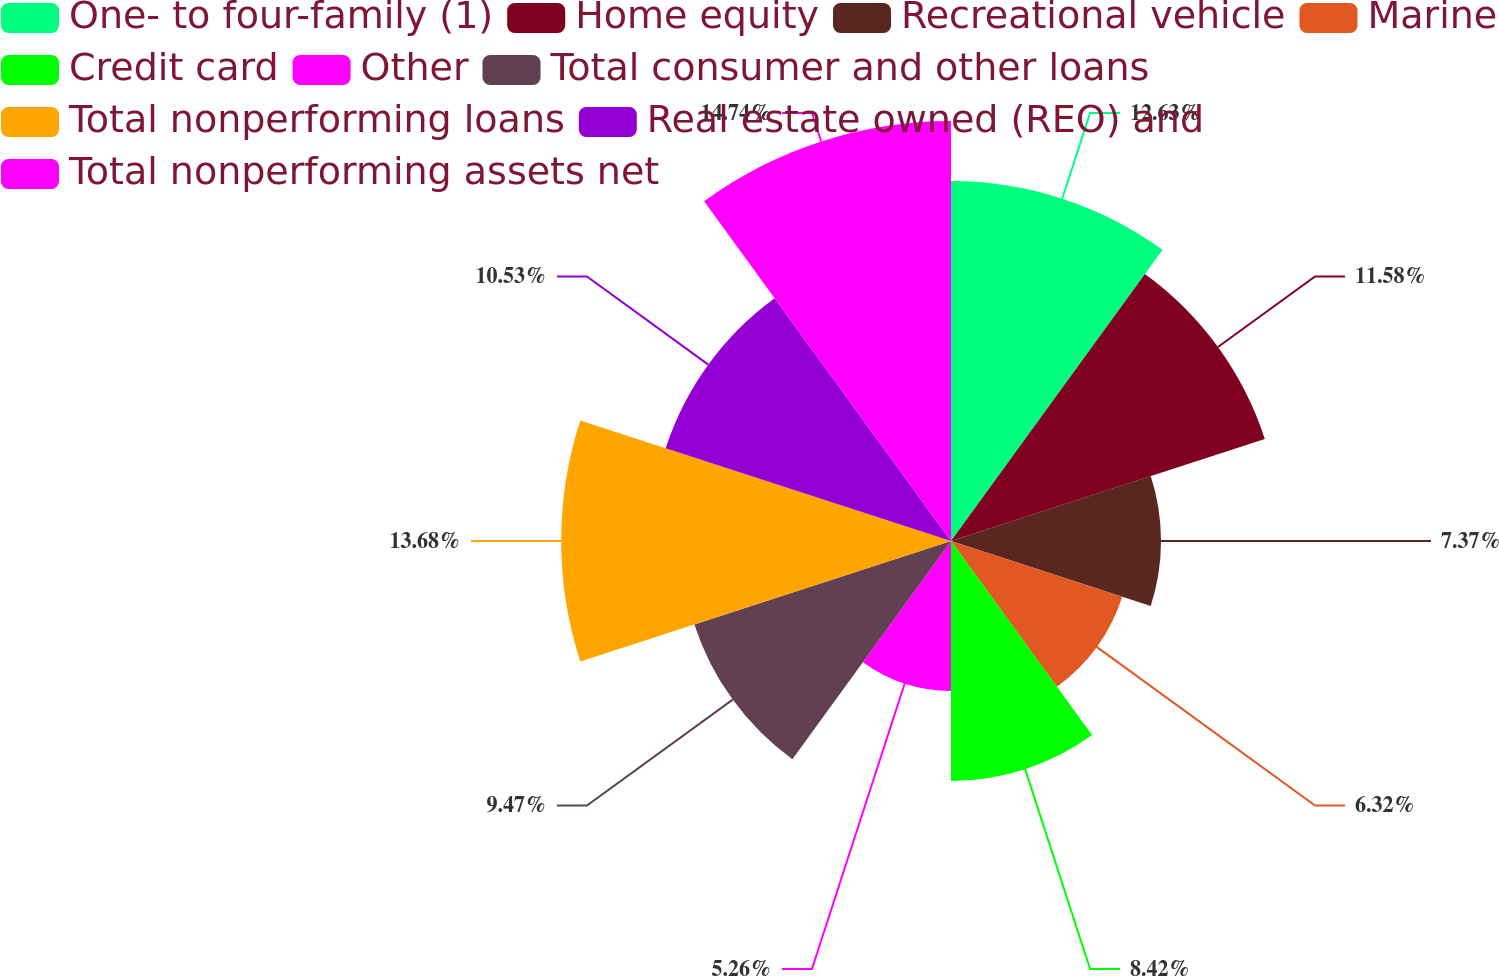Convert chart to OTSL. <chart><loc_0><loc_0><loc_500><loc_500><pie_chart><fcel>One- to four-family (1)<fcel>Home equity<fcel>Recreational vehicle<fcel>Marine<fcel>Credit card<fcel>Other<fcel>Total consumer and other loans<fcel>Total nonperforming loans<fcel>Real estate owned (REO) and<fcel>Total nonperforming assets net<nl><fcel>12.63%<fcel>11.58%<fcel>7.37%<fcel>6.32%<fcel>8.42%<fcel>5.26%<fcel>9.47%<fcel>13.68%<fcel>10.53%<fcel>14.74%<nl></chart> 